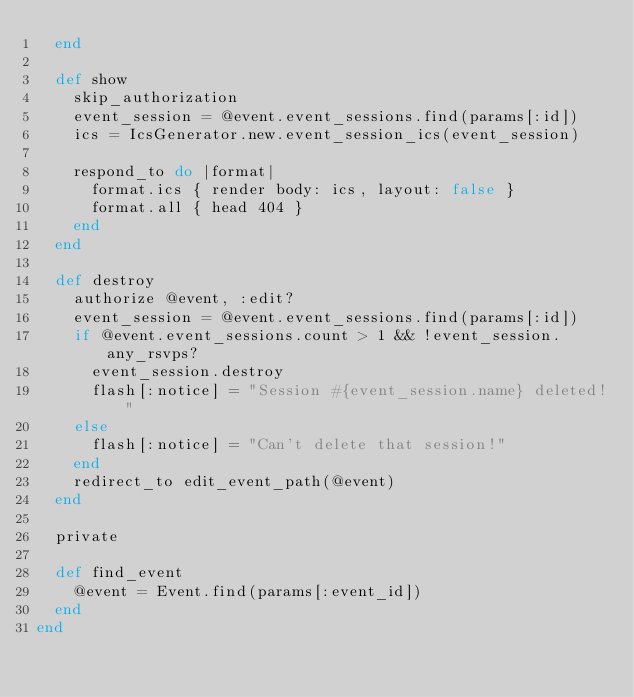Convert code to text. <code><loc_0><loc_0><loc_500><loc_500><_Ruby_>  end

  def show
    skip_authorization
    event_session = @event.event_sessions.find(params[:id])
    ics = IcsGenerator.new.event_session_ics(event_session)

    respond_to do |format|
      format.ics { render body: ics, layout: false }
      format.all { head 404 }
    end
  end

  def destroy
    authorize @event, :edit?
    event_session = @event.event_sessions.find(params[:id])
    if @event.event_sessions.count > 1 && !event_session.any_rsvps?
      event_session.destroy
      flash[:notice] = "Session #{event_session.name} deleted!"
    else
      flash[:notice] = "Can't delete that session!"
    end
    redirect_to edit_event_path(@event)
  end

  private

  def find_event
    @event = Event.find(params[:event_id])
  end
end
</code> 